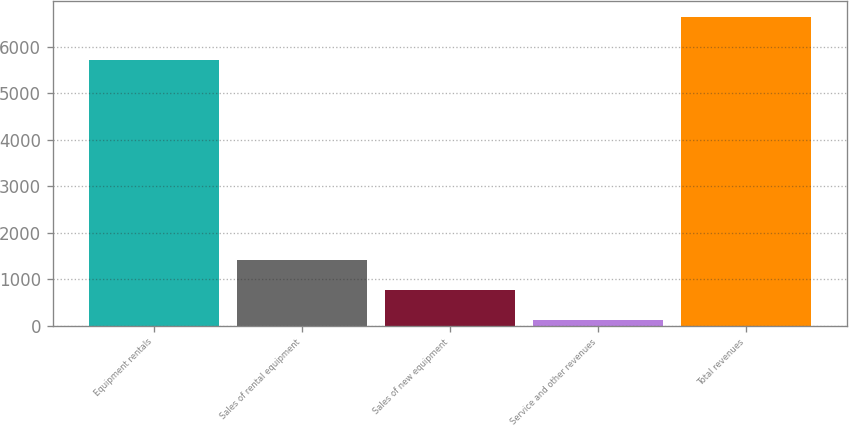<chart> <loc_0><loc_0><loc_500><loc_500><bar_chart><fcel>Equipment rentals<fcel>Sales of rental equipment<fcel>Sales of new equipment<fcel>Service and other revenues<fcel>Total revenues<nl><fcel>5715<fcel>1422.6<fcel>770.3<fcel>118<fcel>6641<nl></chart> 